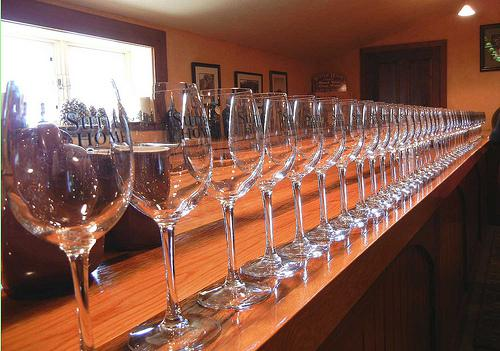Question: who is in the picture?
Choices:
A. Mario Bataley.
B. Cat Cora.
C. Gordon Ramsey.
D. No one.
Answer with the letter. Answer: D Question: what color is the wall?
Choices:
A. White.
B. Grey.
C. Green.
D. Beige.
Answer with the letter. Answer: D 